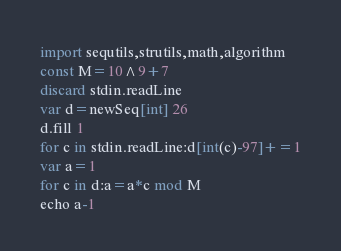Convert code to text. <code><loc_0><loc_0><loc_500><loc_500><_Nim_>import sequtils,strutils,math,algorithm
const M=10^9+7
discard stdin.readLine
var d=newSeq[int] 26
d.fill 1
for c in stdin.readLine:d[int(c)-97]+=1
var a=1
for c in d:a=a*c mod M
echo a-1</code> 